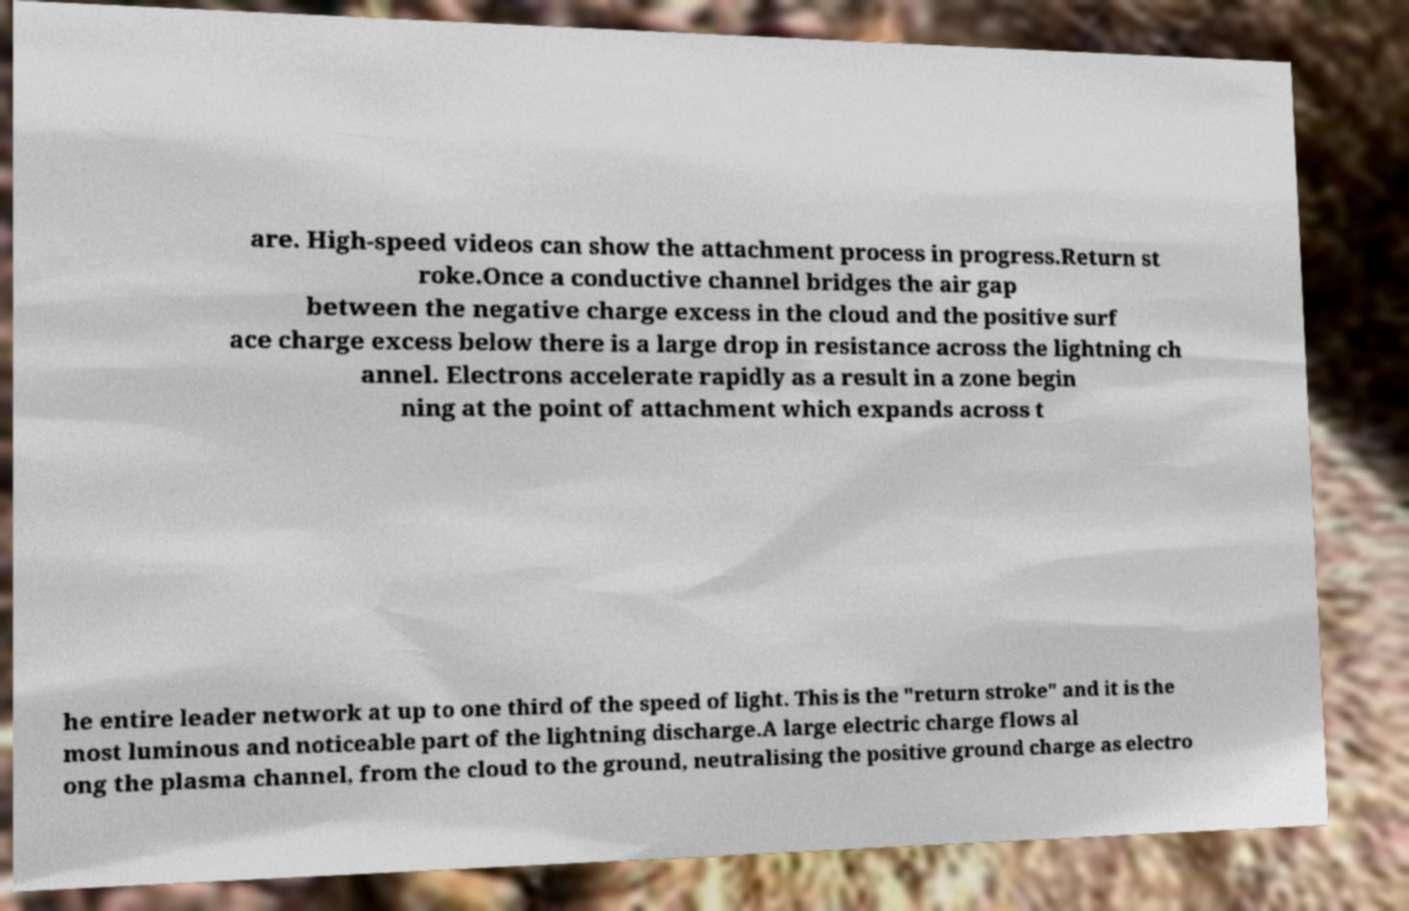For documentation purposes, I need the text within this image transcribed. Could you provide that? are. High-speed videos can show the attachment process in progress.Return st roke.Once a conductive channel bridges the air gap between the negative charge excess in the cloud and the positive surf ace charge excess below there is a large drop in resistance across the lightning ch annel. Electrons accelerate rapidly as a result in a zone begin ning at the point of attachment which expands across t he entire leader network at up to one third of the speed of light. This is the "return stroke" and it is the most luminous and noticeable part of the lightning discharge.A large electric charge flows al ong the plasma channel, from the cloud to the ground, neutralising the positive ground charge as electro 